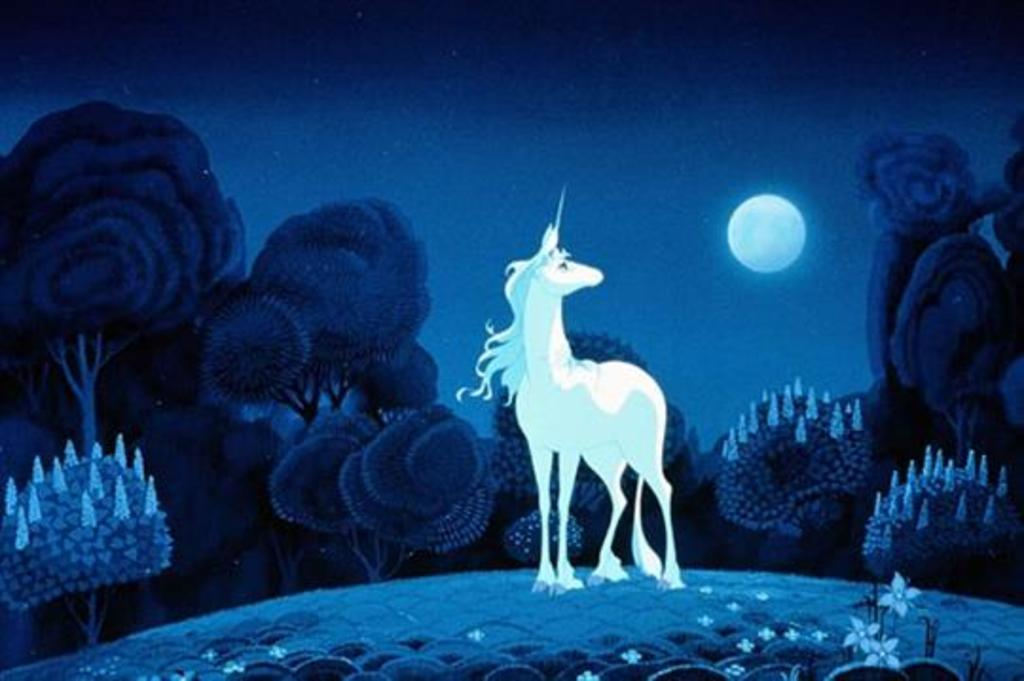What type of animal can be seen in the image? There is an animal in the image, but its specific type cannot be determined from the provided facts. What color is the animal in the image? The animal is white in color. What can be seen in the background of the image? There are trees visible in the background of the image. What celestial object is present in the image? The moon is present in the image, and it is also white in color. What type of dress is the animal wearing in the image? There is no dress present in the image, as the animal is not a human and does not wear clothing. --- Facts: 1. There is a person in the image. 2. The person is wearing a hat. 3. The person is holding a book. 4. There is a table in the image. 5. The table has a lamp on it. Absurd Topics: parrot, ocean, bicycle Conversation: What is the main subject of the image? The main subject of the image is a person. What is the person wearing in the image? The person is wearing a hat. What object is the person holding in the image? The person is holding a book. What piece of furniture is present in the image? There is a table in the image. What object is on the table in the image? The table has a lamp on it. Reasoning: Let's think step by step in order to produce the conversation. We start by identifying the main subject of the image, which is a person. We then describe the person's attire, noting that they are wearing a hat. Next, we mention the object the person is holding, which is a book. We then identify the piece of furniture present in the image, which is a table. Finally, we describe the object on the table, which is a lamp. Absurd Question/Answer: Can you see any parrots flying over the ocean in the image? There is no mention of parrots or the ocean in the provided facts, so it cannot be determined if they are present in the image. 